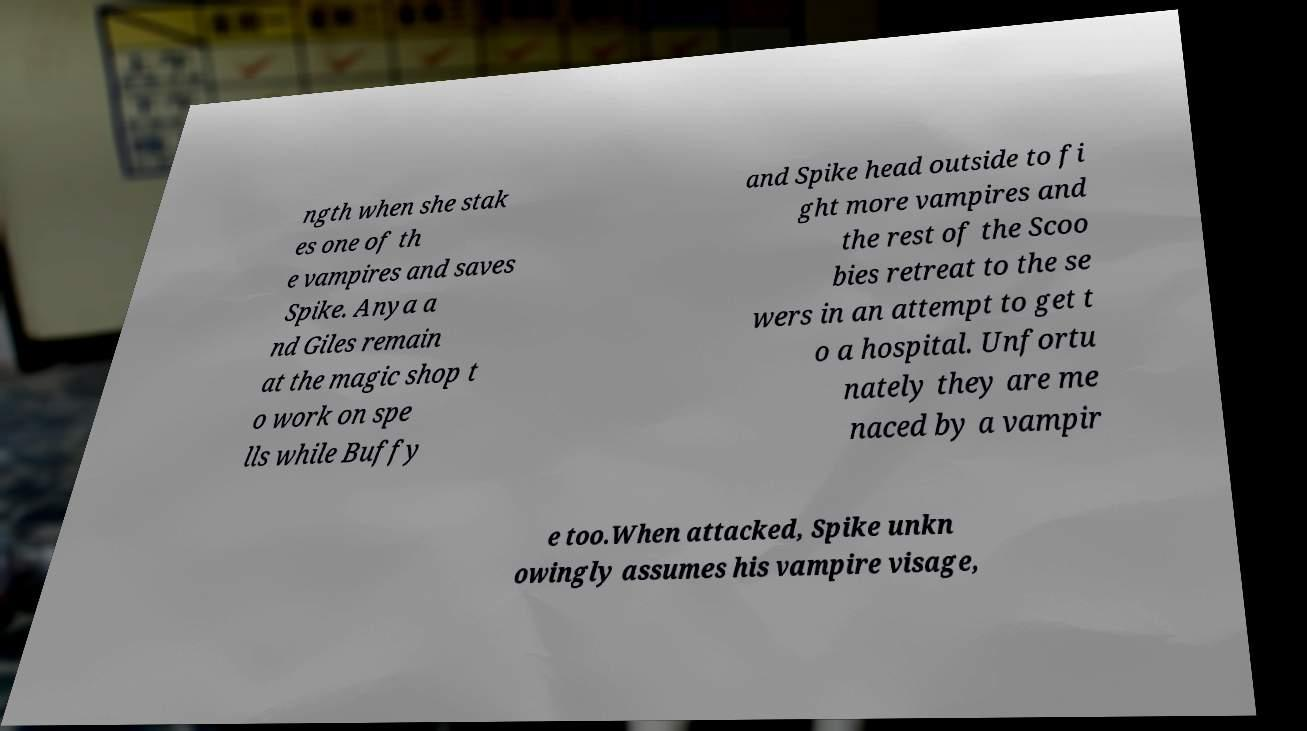Can you read and provide the text displayed in the image?This photo seems to have some interesting text. Can you extract and type it out for me? ngth when she stak es one of th e vampires and saves Spike. Anya a nd Giles remain at the magic shop t o work on spe lls while Buffy and Spike head outside to fi ght more vampires and the rest of the Scoo bies retreat to the se wers in an attempt to get t o a hospital. Unfortu nately they are me naced by a vampir e too.When attacked, Spike unkn owingly assumes his vampire visage, 